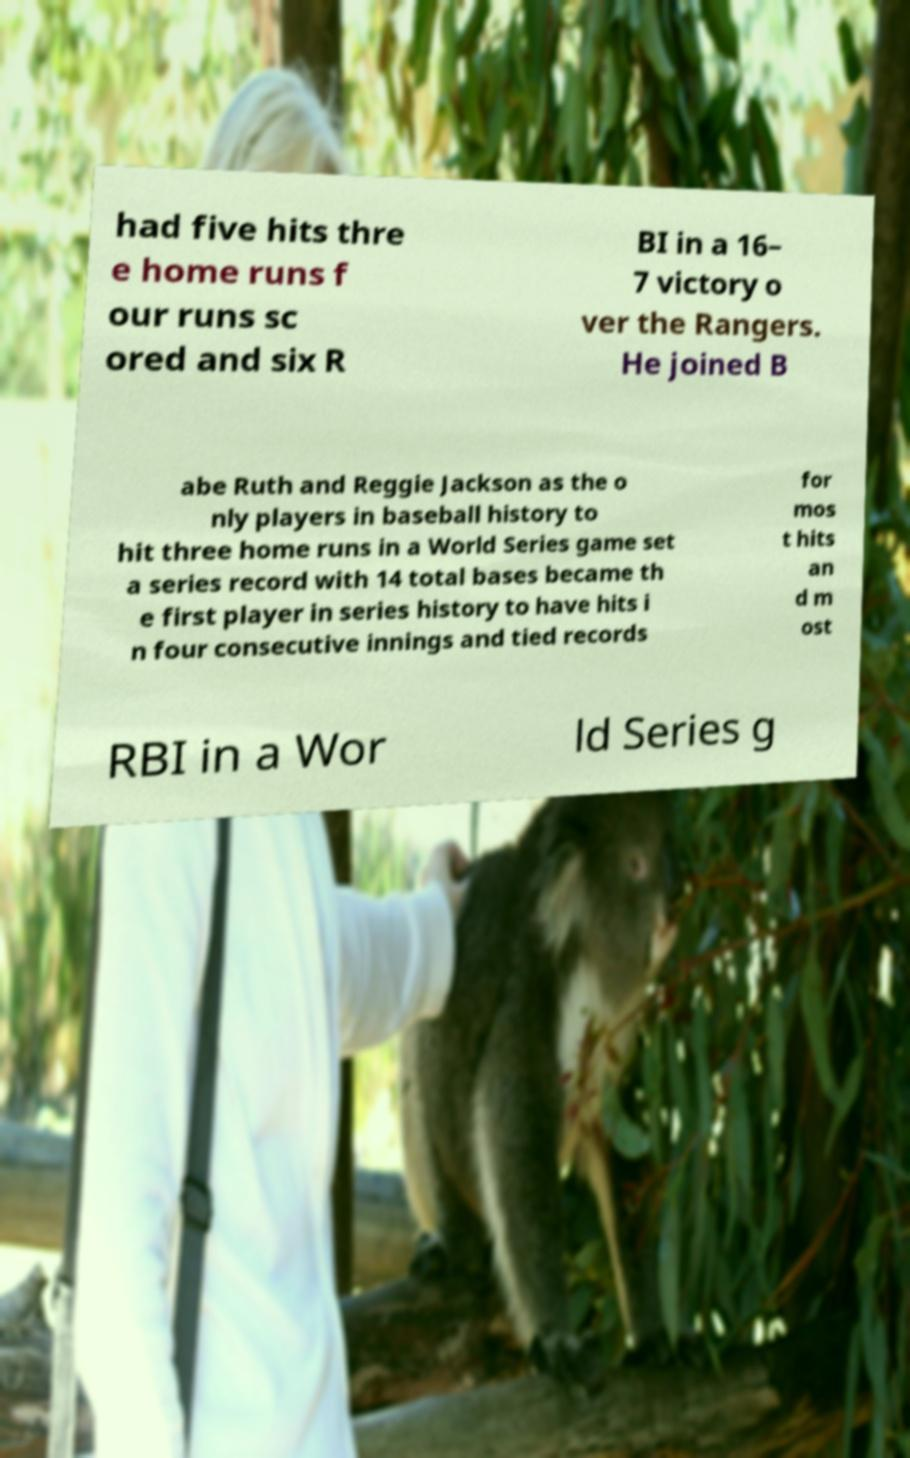Can you accurately transcribe the text from the provided image for me? had five hits thre e home runs f our runs sc ored and six R BI in a 16– 7 victory o ver the Rangers. He joined B abe Ruth and Reggie Jackson as the o nly players in baseball history to hit three home runs in a World Series game set a series record with 14 total bases became th e first player in series history to have hits i n four consecutive innings and tied records for mos t hits an d m ost RBI in a Wor ld Series g 